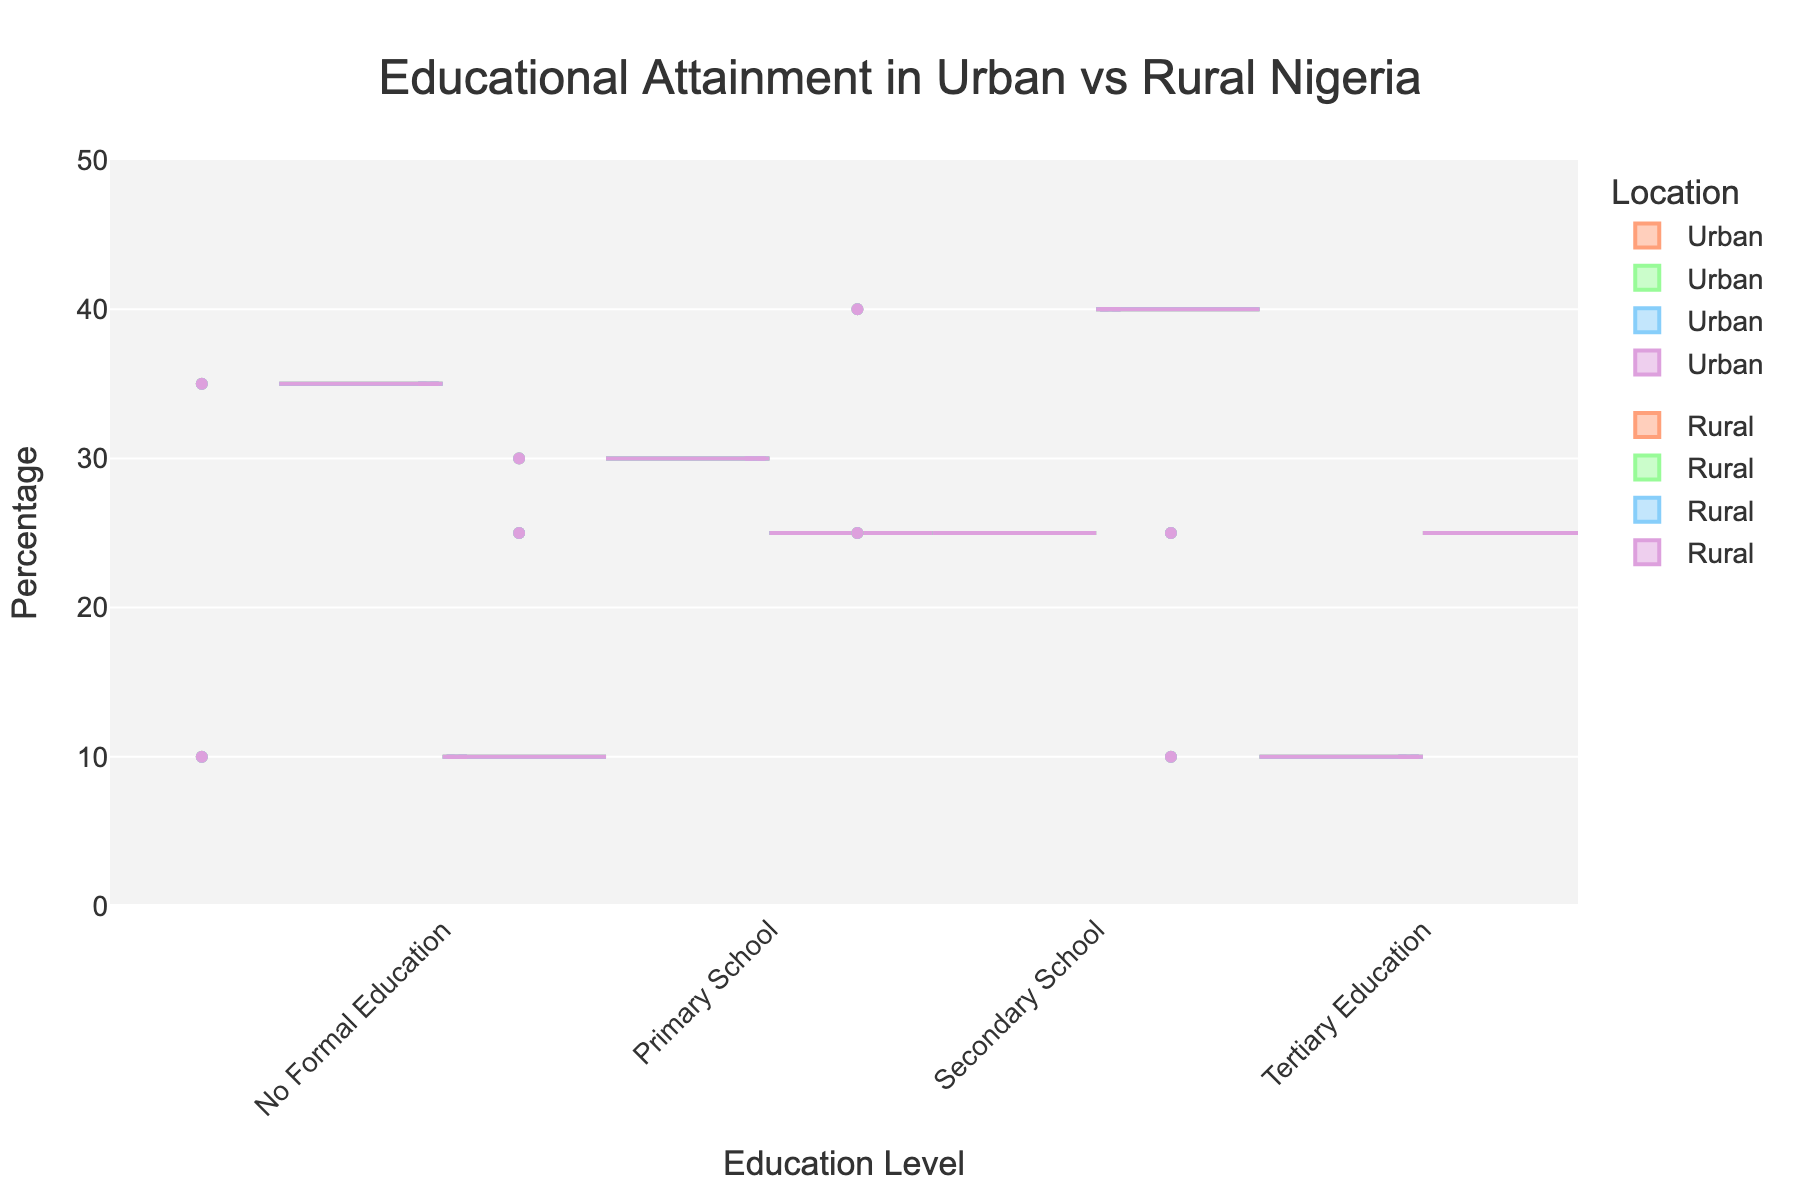Which education level has the highest percentage in rural areas? From the graph, the height of the violin plot shows the percentage distribution. The highest peak for the rural area is at "No Formal Education."
Answer: No Formal Education Which education level has the lowest level of attainment in urban areas? Examining the urban section of the split violin chart, the shortest plot corresponds to "No Formal Education."
Answer: No Formal Education What is the difference in the percentage of people with tertiary education between urban and rural areas? The urban percentage for tertiary education is 25%, and the rural percentage is 10%. Subtracting them gives 25% - 10% = 15%.
Answer: 15% How do the percentages for primary school attainment compare between urban and rural areas? The percentage for primary school attainment is 25% for urban and 30% for rural. Comparatively, rural areas have a higher percentage.
Answer: Rural > Urban Which location has a higher percentage of people with secondary school education, urban or rural? The urban percentage for secondary school education is 40%, whereas it is 25% in rural areas. Therefore, urban areas have a higher percentage.
Answer: Urban What is the average percentage of people with primary and secondary education in rural areas? The percentage for primary education is 30%, and for secondary education, it's 25%. The average is (30 + 25) / 2 = 27.5%.
Answer: 27.5% In which location do more people have no formal education, and by how much? The percentage of people with no formal education in rural areas is 35%, and in urban areas, it is 10%. The difference is 35% - 10% = 25%.
Answer: Rural by 25% How does the distribution of tertiary education in urban areas compare to that in rural areas? Visually, the violin plot for tertiary education in urban areas is wider and taller than that for rural areas, indicating a higher percentage in urban areas.
Answer: Urban > Rural What is the total percentage of people with either secondary or tertiary education in urban areas? The urban percentages for secondary education and tertiary education are 40% and 25%, respectively. The total is 40% + 25% = 65%.
Answer: 65% Is there a more balanced distribution of educational attainment in urban or rural areas? The urban area shows more equally distributed percentages across education levels compared to rural areas, which has a high peak at "No Formal Education."
Answer: Urban 